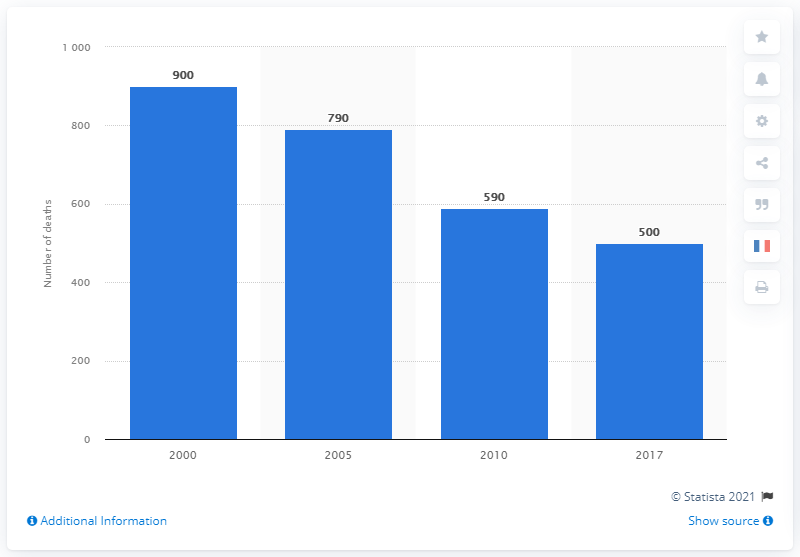Identify some key points in this picture. In 2000, there were approximately 900 deaths due to AIDS in France. 